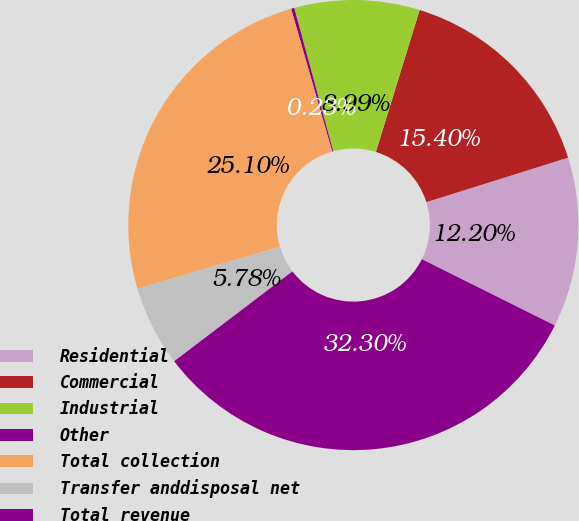Convert chart. <chart><loc_0><loc_0><loc_500><loc_500><pie_chart><fcel>Residential<fcel>Commercial<fcel>Industrial<fcel>Other<fcel>Total collection<fcel>Transfer anddisposal net<fcel>Total revenue<nl><fcel>12.2%<fcel>15.4%<fcel>8.99%<fcel>0.23%<fcel>25.1%<fcel>5.78%<fcel>32.3%<nl></chart> 